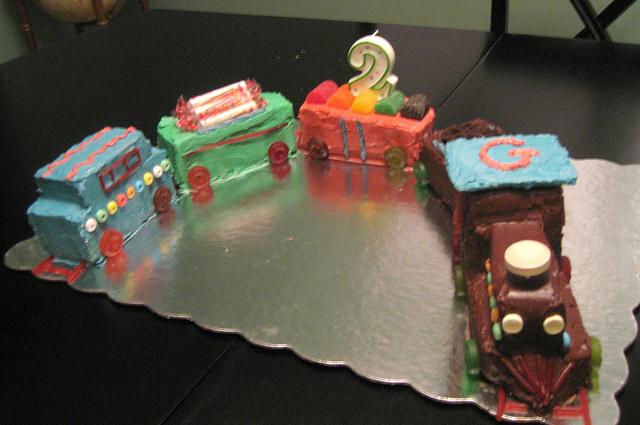Could this be someone's birthday?
Be succinct. Yes. How old is the birthday person?
Quick response, please. 2. What are the wheels made of?
Give a very brief answer. Lifesavers. How old is the child this birthday cake is for?
Concise answer only. 2. How many wheels have the train?
Give a very brief answer. 20. Is this a cake?
Write a very short answer. Yes. 